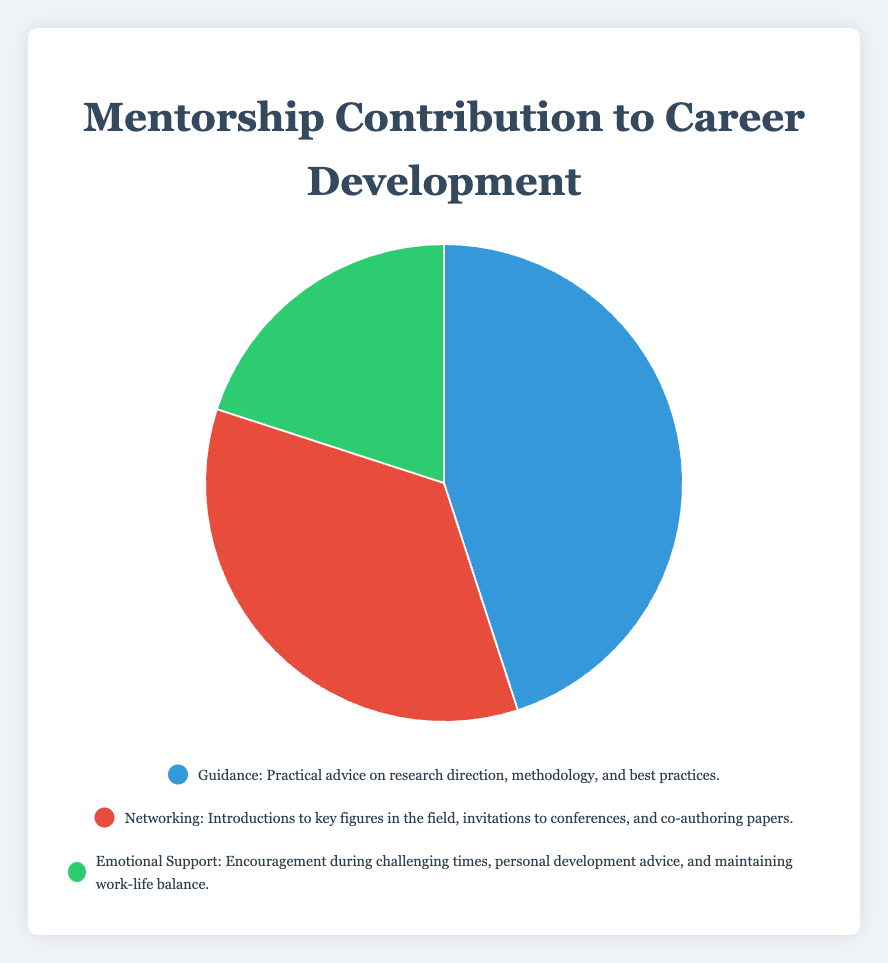What's the largest category in the pie chart? The largest category in the pie chart is the one with the highest percentage. It shows that "Guidance" contributes 45% to career development.
Answer: Guidance Which category has the smallest contribution? The smallest contribution is represented by the category with the lowest percentage, which is "Emotional Support" at 20%.
Answer: Emotional Support What is the total percentage contribution of "Guidance" and "Networking"? Sum the percentages of "Guidance" (45%) and "Networking" (35%): 45 + 35 = 80%.
Answer: 80% Is the percentage contribution of "Networking" greater than "Emotional Support"? Compare the percentages of "Networking" (35%) and "Emotional Support" (20%). 35% is greater than 20%.
Answer: Yes Which category is represented by the blue color? The blue-colored segment of the pie chart represents "Guidance".
Answer: Guidance Calculate the difference in percentage between the largest and smallest categories. The largest category is "Guidance" at 45% and the smallest is "Emotional Support" at 20%. The difference is 45 - 20 = 25%.
Answer: 25% If the total contribution increases such that "Emotional Support" now makes up 25%, what is the new percentage contribution of the remaining categories combined? If "Emotional Support" is 25%, the total for "Guidance" and "Networking" is 100 - 25 = 75%.
Answer: 75% What color represents the "Networking" category? The red-colored segment of the pie chart represents "Networking".
Answer: Red How much more does "Guidance" contribute compared to "Networking"? Subtract the percentage of "Networking" (35%) from the percentage of "Guidance" (45%): 45 - 35 = 10%.
Answer: 10% Which of the categories is visualized using green color? The green segment of the pie chart represents "Emotional Support".
Answer: Emotional Support 